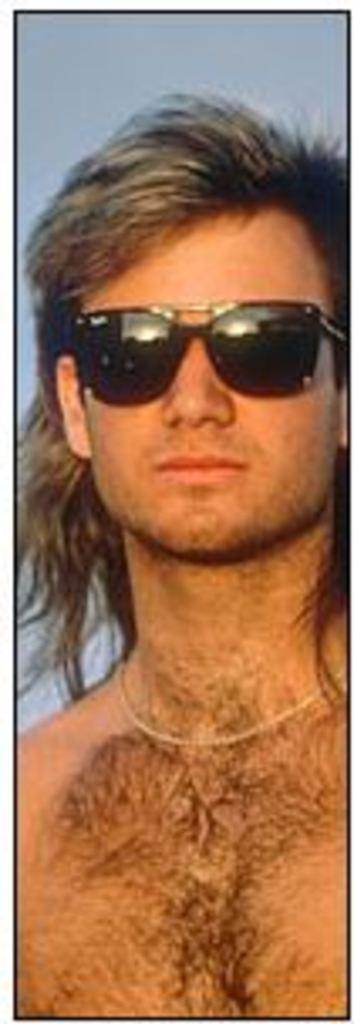Who is present in the image? There is a man in the image. What is the man wearing on his face? The man is wearing goggles. What color is the background of the image? The background of the image is blue. What type of linen is being used to cover the vessel in the image? There is no vessel or linen present in the image. How many bits can be seen in the image? There are no bits present in the image. 